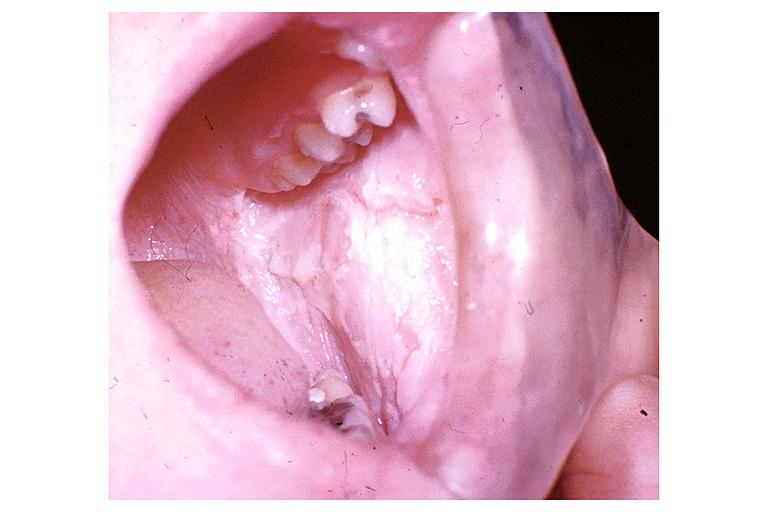does this image show white sponge nevus?
Answer the question using a single word or phrase. Yes 